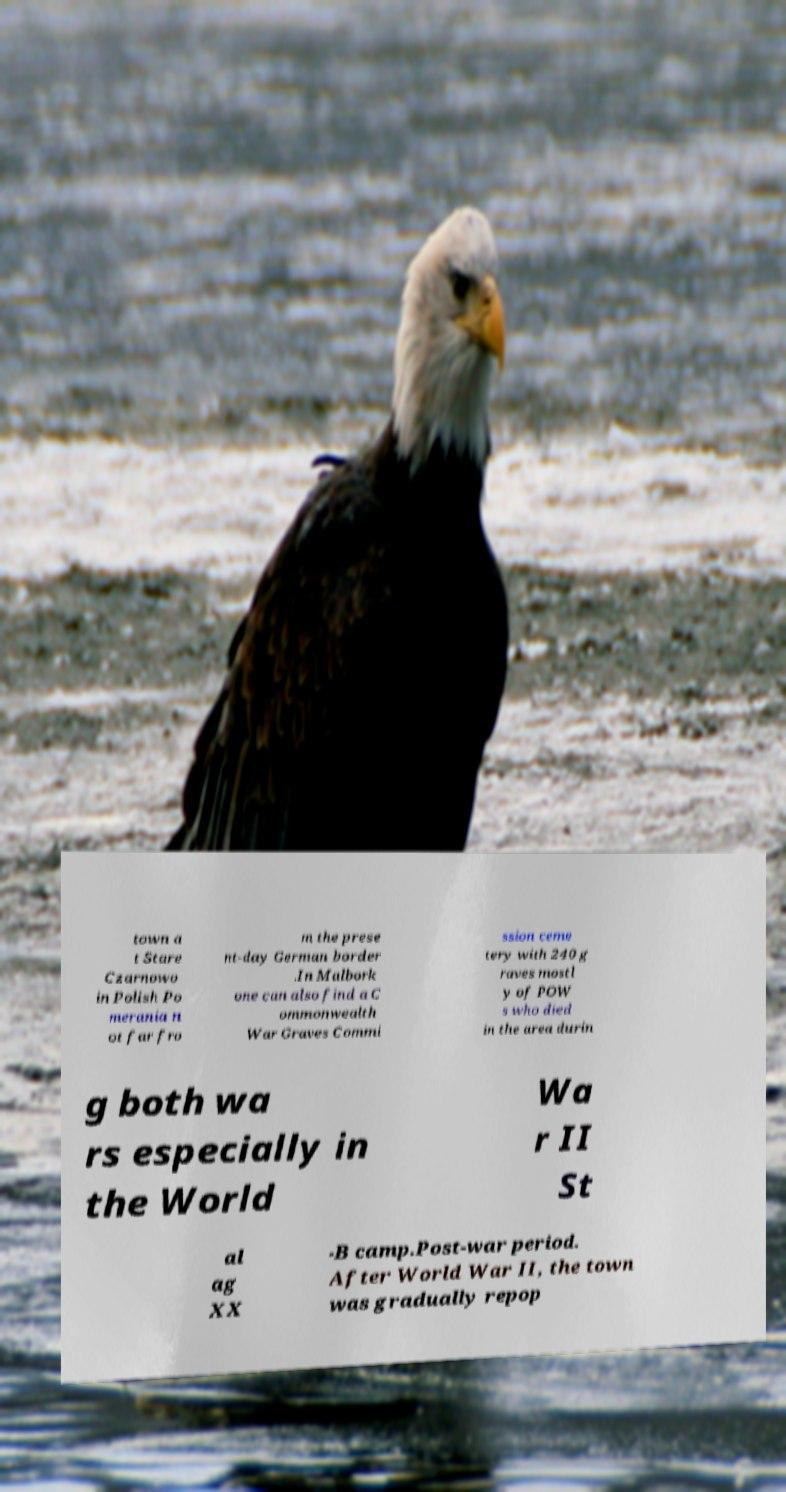Could you extract and type out the text from this image? town a t Stare Czarnowo in Polish Po merania n ot far fro m the prese nt-day German border .In Malbork one can also find a C ommonwealth War Graves Commi ssion ceme tery with 240 g raves mostl y of POW s who died in the area durin g both wa rs especially in the World Wa r II St al ag XX -B camp.Post-war period. After World War II, the town was gradually repop 